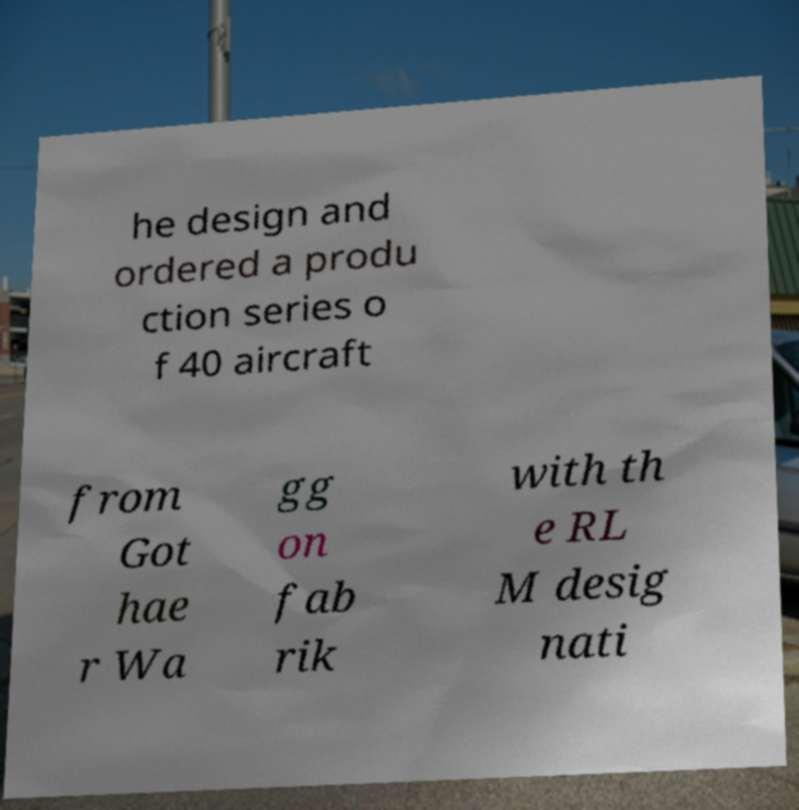There's text embedded in this image that I need extracted. Can you transcribe it verbatim? he design and ordered a produ ction series o f 40 aircraft from Got hae r Wa gg on fab rik with th e RL M desig nati 